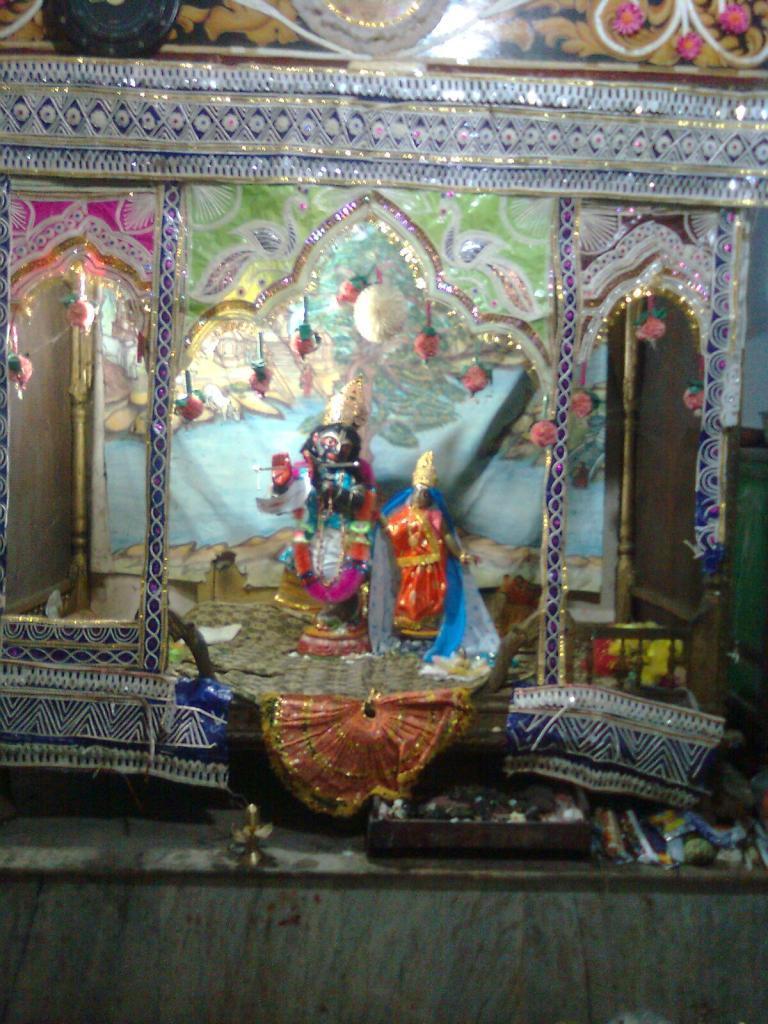How would you summarize this image in a sentence or two? In the image we can see there are two lord statues. This is a floor and these are the decorative items. 